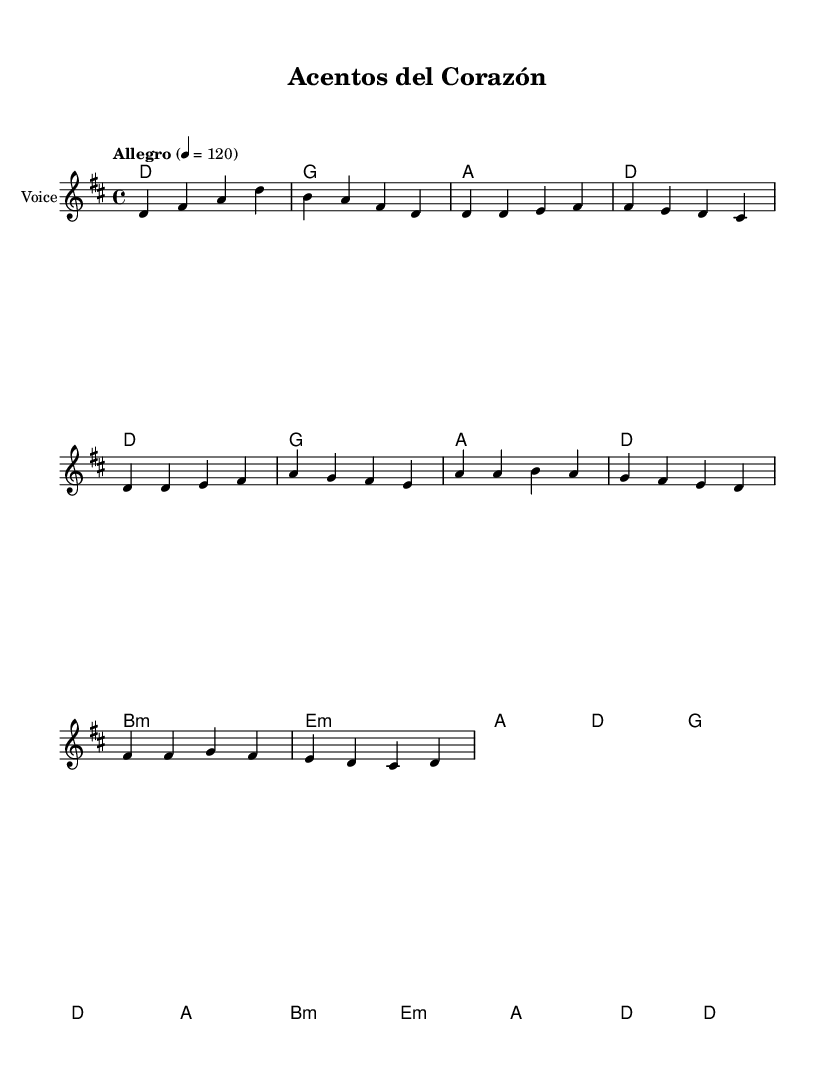What is the key signature of this music? The key signature indicated in the global settings is D major, which consists of two sharps: F# and C#.
Answer: D major What is the time signature of this piece? The time signature provided in the global settings is 4/4, which indicates four beats per measure.
Answer: 4/4 What is the tempo marking of the piece? The tempo marking indicates "Allegro" at a speed of 120 beats per minute. This means the piece should be played quickly.
Answer: Allegro 4 = 120 How many measures are in the verse? Counting the individual measures in the verse, there are a total of four measures present.
Answer: 4 What chords are used in the chorus? The chords listed for the chorus are G, D, A, and B minor, representing the harmonic structure underpinning that section.
Answer: G, D, A, B minor What is the lyric theme presented in the verse? The verse lyrics discuss exploring different Latin American accents and dialects, reflecting the diversity of the region.
Answer: Different Latin American accents and dialects Which musical approach does this piece embody in terms of its cultural focus? The piece embodies the approach of celebrating unity through diversity, particularly in the context of accent perception in Latin music.
Answer: Unity through diversity 